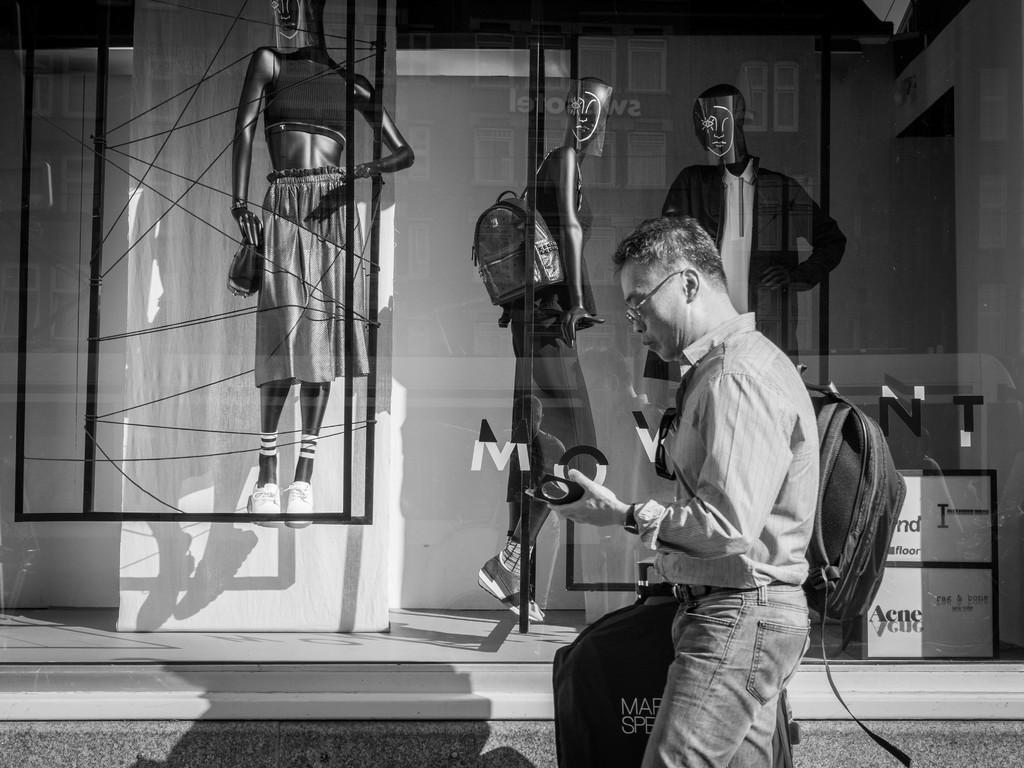Can you describe this image briefly? This is a black and white picture. In this picture, we see a man is standing and he is holding a bag and a black color object in his hand. He is wearing the spectacles and a black backpack. Beside him, we see the glass display from which we can see the mannequins of a woman and the man. In the background, we see a wall. 